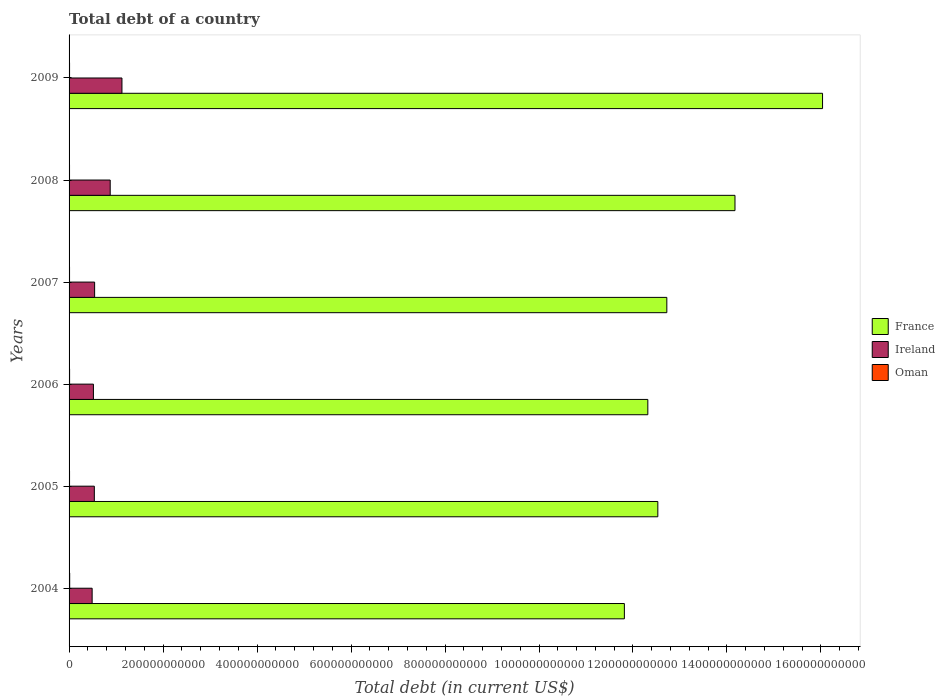How many bars are there on the 2nd tick from the bottom?
Ensure brevity in your answer.  3. What is the debt in Oman in 2007?
Ensure brevity in your answer.  1.00e+09. Across all years, what is the maximum debt in Oman?
Your response must be concise. 1.32e+09. Across all years, what is the minimum debt in Oman?
Keep it short and to the point. 9.65e+08. In which year was the debt in Oman maximum?
Offer a very short reply. 2004. In which year was the debt in France minimum?
Give a very brief answer. 2004. What is the total debt in Oman in the graph?
Offer a terse response. 6.48e+09. What is the difference between the debt in Oman in 2004 and that in 2005?
Ensure brevity in your answer.  3.01e+08. What is the difference between the debt in Oman in 2004 and the debt in France in 2005?
Your answer should be compact. -1.25e+12. What is the average debt in Ireland per year?
Your answer should be compact. 6.82e+1. In the year 2007, what is the difference between the debt in Oman and debt in Ireland?
Make the answer very short. -5.34e+1. In how many years, is the debt in Ireland greater than 960000000000 US$?
Your answer should be compact. 0. What is the ratio of the debt in France in 2007 to that in 2008?
Provide a succinct answer. 0.9. What is the difference between the highest and the second highest debt in Ireland?
Your answer should be very brief. 2.50e+1. What is the difference between the highest and the lowest debt in Oman?
Your response must be concise. 3.54e+08. Is the sum of the debt in Ireland in 2007 and 2008 greater than the maximum debt in Oman across all years?
Keep it short and to the point. Yes. What does the 3rd bar from the top in 2005 represents?
Provide a succinct answer. France. What does the 1st bar from the bottom in 2006 represents?
Ensure brevity in your answer.  France. What is the difference between two consecutive major ticks on the X-axis?
Keep it short and to the point. 2.00e+11. Are the values on the major ticks of X-axis written in scientific E-notation?
Your answer should be very brief. No. Does the graph contain any zero values?
Your answer should be very brief. No. Where does the legend appear in the graph?
Offer a very short reply. Center right. How are the legend labels stacked?
Provide a short and direct response. Vertical. What is the title of the graph?
Give a very brief answer. Total debt of a country. What is the label or title of the X-axis?
Offer a very short reply. Total debt (in current US$). What is the Total debt (in current US$) in France in 2004?
Give a very brief answer. 1.18e+12. What is the Total debt (in current US$) of Ireland in 2004?
Your answer should be very brief. 4.91e+1. What is the Total debt (in current US$) in Oman in 2004?
Provide a succinct answer. 1.32e+09. What is the Total debt (in current US$) in France in 2005?
Give a very brief answer. 1.25e+12. What is the Total debt (in current US$) in Ireland in 2005?
Offer a very short reply. 5.38e+1. What is the Total debt (in current US$) in Oman in 2005?
Ensure brevity in your answer.  1.02e+09. What is the Total debt (in current US$) of France in 2006?
Make the answer very short. 1.23e+12. What is the Total debt (in current US$) in Ireland in 2006?
Offer a terse response. 5.18e+1. What is the Total debt (in current US$) in Oman in 2006?
Your answer should be compact. 1.13e+09. What is the Total debt (in current US$) in France in 2007?
Ensure brevity in your answer.  1.27e+12. What is the Total debt (in current US$) in Ireland in 2007?
Make the answer very short. 5.44e+1. What is the Total debt (in current US$) of Oman in 2007?
Your answer should be compact. 1.00e+09. What is the Total debt (in current US$) in France in 2008?
Your answer should be compact. 1.42e+12. What is the Total debt (in current US$) of Ireland in 2008?
Offer a terse response. 8.75e+1. What is the Total debt (in current US$) in Oman in 2008?
Give a very brief answer. 9.65e+08. What is the Total debt (in current US$) of France in 2009?
Ensure brevity in your answer.  1.60e+12. What is the Total debt (in current US$) in Ireland in 2009?
Ensure brevity in your answer.  1.13e+11. What is the Total debt (in current US$) in Oman in 2009?
Keep it short and to the point. 1.04e+09. Across all years, what is the maximum Total debt (in current US$) of France?
Offer a very short reply. 1.60e+12. Across all years, what is the maximum Total debt (in current US$) of Ireland?
Your answer should be very brief. 1.13e+11. Across all years, what is the maximum Total debt (in current US$) of Oman?
Give a very brief answer. 1.32e+09. Across all years, what is the minimum Total debt (in current US$) of France?
Your answer should be very brief. 1.18e+12. Across all years, what is the minimum Total debt (in current US$) in Ireland?
Offer a very short reply. 4.91e+1. Across all years, what is the minimum Total debt (in current US$) of Oman?
Your answer should be compact. 9.65e+08. What is the total Total debt (in current US$) in France in the graph?
Offer a terse response. 7.96e+12. What is the total Total debt (in current US$) of Ireland in the graph?
Keep it short and to the point. 4.09e+11. What is the total Total debt (in current US$) of Oman in the graph?
Make the answer very short. 6.48e+09. What is the difference between the Total debt (in current US$) of France in 2004 and that in 2005?
Offer a terse response. -7.12e+1. What is the difference between the Total debt (in current US$) in Ireland in 2004 and that in 2005?
Offer a terse response. -4.66e+09. What is the difference between the Total debt (in current US$) in Oman in 2004 and that in 2005?
Offer a terse response. 3.01e+08. What is the difference between the Total debt (in current US$) of France in 2004 and that in 2006?
Provide a short and direct response. -4.99e+1. What is the difference between the Total debt (in current US$) in Ireland in 2004 and that in 2006?
Provide a short and direct response. -2.70e+09. What is the difference between the Total debt (in current US$) in Oman in 2004 and that in 2006?
Your answer should be compact. 1.92e+08. What is the difference between the Total debt (in current US$) of France in 2004 and that in 2007?
Give a very brief answer. -9.03e+1. What is the difference between the Total debt (in current US$) in Ireland in 2004 and that in 2007?
Your answer should be compact. -5.26e+09. What is the difference between the Total debt (in current US$) in Oman in 2004 and that in 2007?
Provide a short and direct response. 3.18e+08. What is the difference between the Total debt (in current US$) in France in 2004 and that in 2008?
Offer a very short reply. -2.35e+11. What is the difference between the Total debt (in current US$) in Ireland in 2004 and that in 2008?
Provide a short and direct response. -3.84e+1. What is the difference between the Total debt (in current US$) in Oman in 2004 and that in 2008?
Give a very brief answer. 3.54e+08. What is the difference between the Total debt (in current US$) of France in 2004 and that in 2009?
Ensure brevity in your answer.  -4.22e+11. What is the difference between the Total debt (in current US$) of Ireland in 2004 and that in 2009?
Offer a very short reply. -6.34e+1. What is the difference between the Total debt (in current US$) of Oman in 2004 and that in 2009?
Your answer should be compact. 2.74e+08. What is the difference between the Total debt (in current US$) of France in 2005 and that in 2006?
Offer a terse response. 2.13e+1. What is the difference between the Total debt (in current US$) of Ireland in 2005 and that in 2006?
Your response must be concise. 1.96e+09. What is the difference between the Total debt (in current US$) of Oman in 2005 and that in 2006?
Keep it short and to the point. -1.10e+08. What is the difference between the Total debt (in current US$) in France in 2005 and that in 2007?
Offer a very short reply. -1.91e+1. What is the difference between the Total debt (in current US$) of Ireland in 2005 and that in 2007?
Ensure brevity in your answer.  -6.06e+08. What is the difference between the Total debt (in current US$) in Oman in 2005 and that in 2007?
Ensure brevity in your answer.  1.71e+07. What is the difference between the Total debt (in current US$) in France in 2005 and that in 2008?
Your answer should be very brief. -1.64e+11. What is the difference between the Total debt (in current US$) of Ireland in 2005 and that in 2008?
Provide a succinct answer. -3.38e+1. What is the difference between the Total debt (in current US$) in Oman in 2005 and that in 2008?
Ensure brevity in your answer.  5.32e+07. What is the difference between the Total debt (in current US$) in France in 2005 and that in 2009?
Provide a succinct answer. -3.51e+11. What is the difference between the Total debt (in current US$) of Ireland in 2005 and that in 2009?
Offer a terse response. -5.88e+1. What is the difference between the Total debt (in current US$) of Oman in 2005 and that in 2009?
Your response must be concise. -2.68e+07. What is the difference between the Total debt (in current US$) of France in 2006 and that in 2007?
Your answer should be very brief. -4.04e+1. What is the difference between the Total debt (in current US$) in Ireland in 2006 and that in 2007?
Offer a very short reply. -2.56e+09. What is the difference between the Total debt (in current US$) in Oman in 2006 and that in 2007?
Offer a terse response. 1.27e+08. What is the difference between the Total debt (in current US$) in France in 2006 and that in 2008?
Provide a short and direct response. -1.85e+11. What is the difference between the Total debt (in current US$) in Ireland in 2006 and that in 2008?
Make the answer very short. -3.57e+1. What is the difference between the Total debt (in current US$) in Oman in 2006 and that in 2008?
Ensure brevity in your answer.  1.63e+08. What is the difference between the Total debt (in current US$) of France in 2006 and that in 2009?
Offer a terse response. -3.72e+11. What is the difference between the Total debt (in current US$) in Ireland in 2006 and that in 2009?
Your answer should be very brief. -6.07e+1. What is the difference between the Total debt (in current US$) of Oman in 2006 and that in 2009?
Ensure brevity in your answer.  8.28e+07. What is the difference between the Total debt (in current US$) in France in 2007 and that in 2008?
Make the answer very short. -1.45e+11. What is the difference between the Total debt (in current US$) of Ireland in 2007 and that in 2008?
Your answer should be very brief. -3.32e+1. What is the difference between the Total debt (in current US$) of Oman in 2007 and that in 2008?
Your answer should be very brief. 3.61e+07. What is the difference between the Total debt (in current US$) of France in 2007 and that in 2009?
Ensure brevity in your answer.  -3.31e+11. What is the difference between the Total debt (in current US$) of Ireland in 2007 and that in 2009?
Keep it short and to the point. -5.82e+1. What is the difference between the Total debt (in current US$) of Oman in 2007 and that in 2009?
Make the answer very short. -4.39e+07. What is the difference between the Total debt (in current US$) of France in 2008 and that in 2009?
Make the answer very short. -1.86e+11. What is the difference between the Total debt (in current US$) in Ireland in 2008 and that in 2009?
Offer a terse response. -2.50e+1. What is the difference between the Total debt (in current US$) in Oman in 2008 and that in 2009?
Ensure brevity in your answer.  -8.00e+07. What is the difference between the Total debt (in current US$) in France in 2004 and the Total debt (in current US$) in Ireland in 2005?
Offer a very short reply. 1.13e+12. What is the difference between the Total debt (in current US$) in France in 2004 and the Total debt (in current US$) in Oman in 2005?
Provide a short and direct response. 1.18e+12. What is the difference between the Total debt (in current US$) of Ireland in 2004 and the Total debt (in current US$) of Oman in 2005?
Your answer should be very brief. 4.81e+1. What is the difference between the Total debt (in current US$) in France in 2004 and the Total debt (in current US$) in Ireland in 2006?
Offer a very short reply. 1.13e+12. What is the difference between the Total debt (in current US$) of France in 2004 and the Total debt (in current US$) of Oman in 2006?
Give a very brief answer. 1.18e+12. What is the difference between the Total debt (in current US$) of Ireland in 2004 and the Total debt (in current US$) of Oman in 2006?
Keep it short and to the point. 4.80e+1. What is the difference between the Total debt (in current US$) of France in 2004 and the Total debt (in current US$) of Ireland in 2007?
Ensure brevity in your answer.  1.13e+12. What is the difference between the Total debt (in current US$) in France in 2004 and the Total debt (in current US$) in Oman in 2007?
Your answer should be very brief. 1.18e+12. What is the difference between the Total debt (in current US$) in Ireland in 2004 and the Total debt (in current US$) in Oman in 2007?
Your response must be concise. 4.81e+1. What is the difference between the Total debt (in current US$) in France in 2004 and the Total debt (in current US$) in Ireland in 2008?
Provide a succinct answer. 1.09e+12. What is the difference between the Total debt (in current US$) of France in 2004 and the Total debt (in current US$) of Oman in 2008?
Your response must be concise. 1.18e+12. What is the difference between the Total debt (in current US$) in Ireland in 2004 and the Total debt (in current US$) in Oman in 2008?
Your answer should be compact. 4.81e+1. What is the difference between the Total debt (in current US$) of France in 2004 and the Total debt (in current US$) of Ireland in 2009?
Provide a short and direct response. 1.07e+12. What is the difference between the Total debt (in current US$) of France in 2004 and the Total debt (in current US$) of Oman in 2009?
Make the answer very short. 1.18e+12. What is the difference between the Total debt (in current US$) in Ireland in 2004 and the Total debt (in current US$) in Oman in 2009?
Offer a very short reply. 4.81e+1. What is the difference between the Total debt (in current US$) in France in 2005 and the Total debt (in current US$) in Ireland in 2006?
Your response must be concise. 1.20e+12. What is the difference between the Total debt (in current US$) of France in 2005 and the Total debt (in current US$) of Oman in 2006?
Give a very brief answer. 1.25e+12. What is the difference between the Total debt (in current US$) of Ireland in 2005 and the Total debt (in current US$) of Oman in 2006?
Offer a very short reply. 5.26e+1. What is the difference between the Total debt (in current US$) in France in 2005 and the Total debt (in current US$) in Ireland in 2007?
Keep it short and to the point. 1.20e+12. What is the difference between the Total debt (in current US$) in France in 2005 and the Total debt (in current US$) in Oman in 2007?
Provide a succinct answer. 1.25e+12. What is the difference between the Total debt (in current US$) in Ireland in 2005 and the Total debt (in current US$) in Oman in 2007?
Make the answer very short. 5.28e+1. What is the difference between the Total debt (in current US$) of France in 2005 and the Total debt (in current US$) of Ireland in 2008?
Offer a terse response. 1.17e+12. What is the difference between the Total debt (in current US$) in France in 2005 and the Total debt (in current US$) in Oman in 2008?
Your answer should be very brief. 1.25e+12. What is the difference between the Total debt (in current US$) in Ireland in 2005 and the Total debt (in current US$) in Oman in 2008?
Offer a very short reply. 5.28e+1. What is the difference between the Total debt (in current US$) in France in 2005 and the Total debt (in current US$) in Ireland in 2009?
Keep it short and to the point. 1.14e+12. What is the difference between the Total debt (in current US$) of France in 2005 and the Total debt (in current US$) of Oman in 2009?
Ensure brevity in your answer.  1.25e+12. What is the difference between the Total debt (in current US$) of Ireland in 2005 and the Total debt (in current US$) of Oman in 2009?
Your answer should be very brief. 5.27e+1. What is the difference between the Total debt (in current US$) of France in 2006 and the Total debt (in current US$) of Ireland in 2007?
Ensure brevity in your answer.  1.18e+12. What is the difference between the Total debt (in current US$) of France in 2006 and the Total debt (in current US$) of Oman in 2007?
Your answer should be very brief. 1.23e+12. What is the difference between the Total debt (in current US$) in Ireland in 2006 and the Total debt (in current US$) in Oman in 2007?
Your answer should be compact. 5.08e+1. What is the difference between the Total debt (in current US$) in France in 2006 and the Total debt (in current US$) in Ireland in 2008?
Your answer should be compact. 1.14e+12. What is the difference between the Total debt (in current US$) in France in 2006 and the Total debt (in current US$) in Oman in 2008?
Your response must be concise. 1.23e+12. What is the difference between the Total debt (in current US$) of Ireland in 2006 and the Total debt (in current US$) of Oman in 2008?
Offer a very short reply. 5.08e+1. What is the difference between the Total debt (in current US$) in France in 2006 and the Total debt (in current US$) in Ireland in 2009?
Provide a succinct answer. 1.12e+12. What is the difference between the Total debt (in current US$) in France in 2006 and the Total debt (in current US$) in Oman in 2009?
Offer a terse response. 1.23e+12. What is the difference between the Total debt (in current US$) in Ireland in 2006 and the Total debt (in current US$) in Oman in 2009?
Keep it short and to the point. 5.08e+1. What is the difference between the Total debt (in current US$) of France in 2007 and the Total debt (in current US$) of Ireland in 2008?
Your answer should be compact. 1.18e+12. What is the difference between the Total debt (in current US$) in France in 2007 and the Total debt (in current US$) in Oman in 2008?
Make the answer very short. 1.27e+12. What is the difference between the Total debt (in current US$) of Ireland in 2007 and the Total debt (in current US$) of Oman in 2008?
Ensure brevity in your answer.  5.34e+1. What is the difference between the Total debt (in current US$) in France in 2007 and the Total debt (in current US$) in Ireland in 2009?
Give a very brief answer. 1.16e+12. What is the difference between the Total debt (in current US$) of France in 2007 and the Total debt (in current US$) of Oman in 2009?
Make the answer very short. 1.27e+12. What is the difference between the Total debt (in current US$) of Ireland in 2007 and the Total debt (in current US$) of Oman in 2009?
Offer a very short reply. 5.33e+1. What is the difference between the Total debt (in current US$) in France in 2008 and the Total debt (in current US$) in Ireland in 2009?
Your answer should be compact. 1.30e+12. What is the difference between the Total debt (in current US$) of France in 2008 and the Total debt (in current US$) of Oman in 2009?
Your response must be concise. 1.42e+12. What is the difference between the Total debt (in current US$) of Ireland in 2008 and the Total debt (in current US$) of Oman in 2009?
Give a very brief answer. 8.65e+1. What is the average Total debt (in current US$) in France per year?
Your answer should be compact. 1.33e+12. What is the average Total debt (in current US$) of Ireland per year?
Keep it short and to the point. 6.82e+1. What is the average Total debt (in current US$) of Oman per year?
Your answer should be very brief. 1.08e+09. In the year 2004, what is the difference between the Total debt (in current US$) of France and Total debt (in current US$) of Ireland?
Your response must be concise. 1.13e+12. In the year 2004, what is the difference between the Total debt (in current US$) in France and Total debt (in current US$) in Oman?
Your answer should be very brief. 1.18e+12. In the year 2004, what is the difference between the Total debt (in current US$) in Ireland and Total debt (in current US$) in Oman?
Keep it short and to the point. 4.78e+1. In the year 2005, what is the difference between the Total debt (in current US$) of France and Total debt (in current US$) of Ireland?
Make the answer very short. 1.20e+12. In the year 2005, what is the difference between the Total debt (in current US$) in France and Total debt (in current US$) in Oman?
Offer a terse response. 1.25e+12. In the year 2005, what is the difference between the Total debt (in current US$) in Ireland and Total debt (in current US$) in Oman?
Offer a very short reply. 5.27e+1. In the year 2006, what is the difference between the Total debt (in current US$) of France and Total debt (in current US$) of Ireland?
Your response must be concise. 1.18e+12. In the year 2006, what is the difference between the Total debt (in current US$) in France and Total debt (in current US$) in Oman?
Provide a succinct answer. 1.23e+12. In the year 2006, what is the difference between the Total debt (in current US$) of Ireland and Total debt (in current US$) of Oman?
Provide a short and direct response. 5.07e+1. In the year 2007, what is the difference between the Total debt (in current US$) in France and Total debt (in current US$) in Ireland?
Your response must be concise. 1.22e+12. In the year 2007, what is the difference between the Total debt (in current US$) of France and Total debt (in current US$) of Oman?
Provide a succinct answer. 1.27e+12. In the year 2007, what is the difference between the Total debt (in current US$) in Ireland and Total debt (in current US$) in Oman?
Your response must be concise. 5.34e+1. In the year 2008, what is the difference between the Total debt (in current US$) in France and Total debt (in current US$) in Ireland?
Your answer should be very brief. 1.33e+12. In the year 2008, what is the difference between the Total debt (in current US$) of France and Total debt (in current US$) of Oman?
Ensure brevity in your answer.  1.42e+12. In the year 2008, what is the difference between the Total debt (in current US$) of Ireland and Total debt (in current US$) of Oman?
Offer a very short reply. 8.66e+1. In the year 2009, what is the difference between the Total debt (in current US$) of France and Total debt (in current US$) of Ireland?
Your answer should be very brief. 1.49e+12. In the year 2009, what is the difference between the Total debt (in current US$) of France and Total debt (in current US$) of Oman?
Your answer should be very brief. 1.60e+12. In the year 2009, what is the difference between the Total debt (in current US$) in Ireland and Total debt (in current US$) in Oman?
Offer a very short reply. 1.11e+11. What is the ratio of the Total debt (in current US$) of France in 2004 to that in 2005?
Your response must be concise. 0.94. What is the ratio of the Total debt (in current US$) of Ireland in 2004 to that in 2005?
Keep it short and to the point. 0.91. What is the ratio of the Total debt (in current US$) of Oman in 2004 to that in 2005?
Offer a very short reply. 1.3. What is the ratio of the Total debt (in current US$) of France in 2004 to that in 2006?
Your answer should be very brief. 0.96. What is the ratio of the Total debt (in current US$) in Ireland in 2004 to that in 2006?
Ensure brevity in your answer.  0.95. What is the ratio of the Total debt (in current US$) in Oman in 2004 to that in 2006?
Offer a very short reply. 1.17. What is the ratio of the Total debt (in current US$) in France in 2004 to that in 2007?
Make the answer very short. 0.93. What is the ratio of the Total debt (in current US$) of Ireland in 2004 to that in 2007?
Offer a very short reply. 0.9. What is the ratio of the Total debt (in current US$) of Oman in 2004 to that in 2007?
Offer a very short reply. 1.32. What is the ratio of the Total debt (in current US$) in France in 2004 to that in 2008?
Your response must be concise. 0.83. What is the ratio of the Total debt (in current US$) in Ireland in 2004 to that in 2008?
Your answer should be very brief. 0.56. What is the ratio of the Total debt (in current US$) in Oman in 2004 to that in 2008?
Give a very brief answer. 1.37. What is the ratio of the Total debt (in current US$) of France in 2004 to that in 2009?
Give a very brief answer. 0.74. What is the ratio of the Total debt (in current US$) of Ireland in 2004 to that in 2009?
Make the answer very short. 0.44. What is the ratio of the Total debt (in current US$) of Oman in 2004 to that in 2009?
Keep it short and to the point. 1.26. What is the ratio of the Total debt (in current US$) in France in 2005 to that in 2006?
Your answer should be compact. 1.02. What is the ratio of the Total debt (in current US$) in Ireland in 2005 to that in 2006?
Your answer should be compact. 1.04. What is the ratio of the Total debt (in current US$) in Oman in 2005 to that in 2006?
Your response must be concise. 0.9. What is the ratio of the Total debt (in current US$) of France in 2005 to that in 2007?
Offer a very short reply. 0.98. What is the ratio of the Total debt (in current US$) in Ireland in 2005 to that in 2007?
Give a very brief answer. 0.99. What is the ratio of the Total debt (in current US$) in Oman in 2005 to that in 2007?
Your answer should be compact. 1.02. What is the ratio of the Total debt (in current US$) in France in 2005 to that in 2008?
Your answer should be compact. 0.88. What is the ratio of the Total debt (in current US$) of Ireland in 2005 to that in 2008?
Provide a succinct answer. 0.61. What is the ratio of the Total debt (in current US$) of Oman in 2005 to that in 2008?
Provide a succinct answer. 1.06. What is the ratio of the Total debt (in current US$) of France in 2005 to that in 2009?
Give a very brief answer. 0.78. What is the ratio of the Total debt (in current US$) of Ireland in 2005 to that in 2009?
Your response must be concise. 0.48. What is the ratio of the Total debt (in current US$) in Oman in 2005 to that in 2009?
Keep it short and to the point. 0.97. What is the ratio of the Total debt (in current US$) in France in 2006 to that in 2007?
Provide a succinct answer. 0.97. What is the ratio of the Total debt (in current US$) in Ireland in 2006 to that in 2007?
Provide a succinct answer. 0.95. What is the ratio of the Total debt (in current US$) in Oman in 2006 to that in 2007?
Your response must be concise. 1.13. What is the ratio of the Total debt (in current US$) in France in 2006 to that in 2008?
Your answer should be very brief. 0.87. What is the ratio of the Total debt (in current US$) of Ireland in 2006 to that in 2008?
Offer a terse response. 0.59. What is the ratio of the Total debt (in current US$) of Oman in 2006 to that in 2008?
Make the answer very short. 1.17. What is the ratio of the Total debt (in current US$) of France in 2006 to that in 2009?
Offer a terse response. 0.77. What is the ratio of the Total debt (in current US$) of Ireland in 2006 to that in 2009?
Your response must be concise. 0.46. What is the ratio of the Total debt (in current US$) of Oman in 2006 to that in 2009?
Keep it short and to the point. 1.08. What is the ratio of the Total debt (in current US$) in France in 2007 to that in 2008?
Offer a terse response. 0.9. What is the ratio of the Total debt (in current US$) of Ireland in 2007 to that in 2008?
Your answer should be compact. 0.62. What is the ratio of the Total debt (in current US$) of Oman in 2007 to that in 2008?
Make the answer very short. 1.04. What is the ratio of the Total debt (in current US$) in France in 2007 to that in 2009?
Offer a very short reply. 0.79. What is the ratio of the Total debt (in current US$) in Ireland in 2007 to that in 2009?
Offer a very short reply. 0.48. What is the ratio of the Total debt (in current US$) of Oman in 2007 to that in 2009?
Ensure brevity in your answer.  0.96. What is the ratio of the Total debt (in current US$) of France in 2008 to that in 2009?
Your answer should be compact. 0.88. What is the ratio of the Total debt (in current US$) in Ireland in 2008 to that in 2009?
Ensure brevity in your answer.  0.78. What is the ratio of the Total debt (in current US$) of Oman in 2008 to that in 2009?
Give a very brief answer. 0.92. What is the difference between the highest and the second highest Total debt (in current US$) of France?
Make the answer very short. 1.86e+11. What is the difference between the highest and the second highest Total debt (in current US$) in Ireland?
Offer a terse response. 2.50e+1. What is the difference between the highest and the second highest Total debt (in current US$) of Oman?
Give a very brief answer. 1.92e+08. What is the difference between the highest and the lowest Total debt (in current US$) in France?
Make the answer very short. 4.22e+11. What is the difference between the highest and the lowest Total debt (in current US$) in Ireland?
Keep it short and to the point. 6.34e+1. What is the difference between the highest and the lowest Total debt (in current US$) of Oman?
Provide a short and direct response. 3.54e+08. 